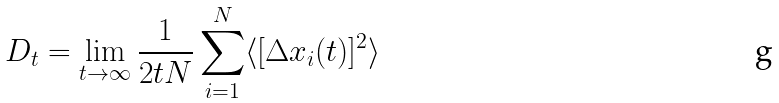<formula> <loc_0><loc_0><loc_500><loc_500>D _ { t } = \lim _ { t \rightarrow \infty } \frac { 1 } { 2 t N } \sum _ { i = 1 } ^ { N } \langle [ \Delta x _ { i } ( t ) ] ^ { 2 } \rangle</formula> 